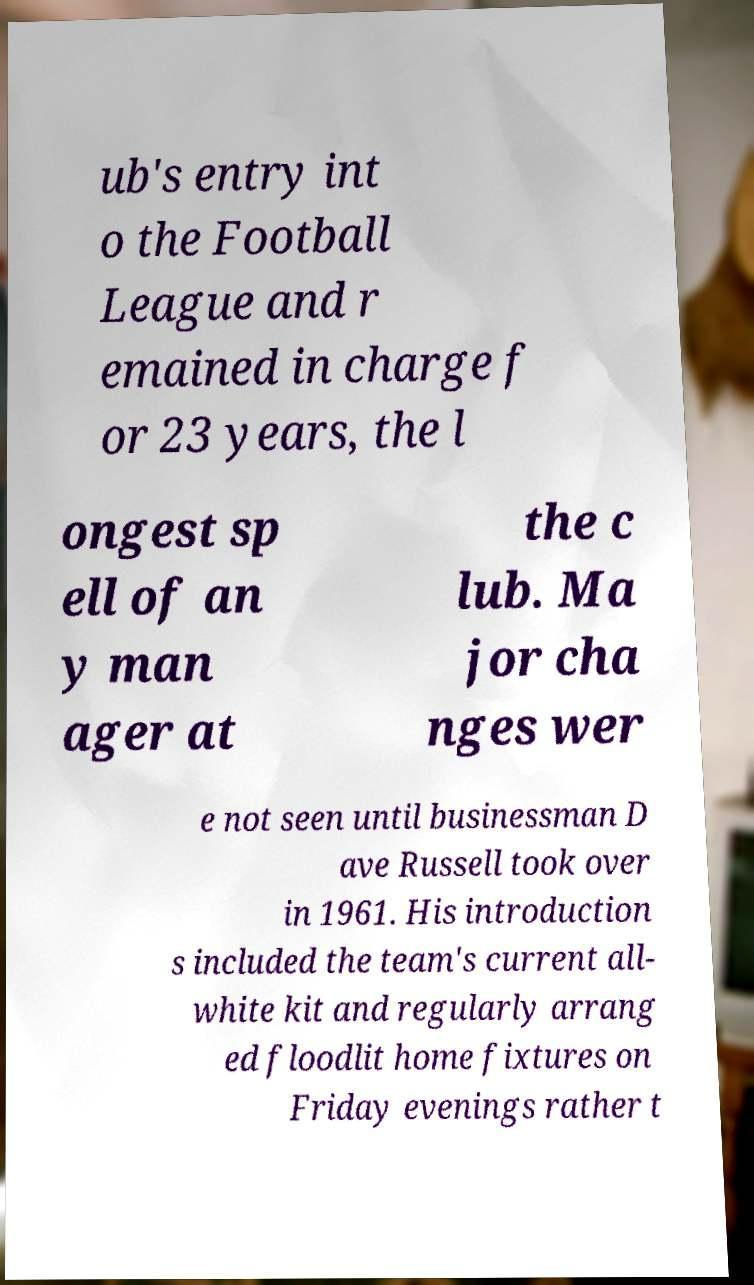Please read and relay the text visible in this image. What does it say? ub's entry int o the Football League and r emained in charge f or 23 years, the l ongest sp ell of an y man ager at the c lub. Ma jor cha nges wer e not seen until businessman D ave Russell took over in 1961. His introduction s included the team's current all- white kit and regularly arrang ed floodlit home fixtures on Friday evenings rather t 